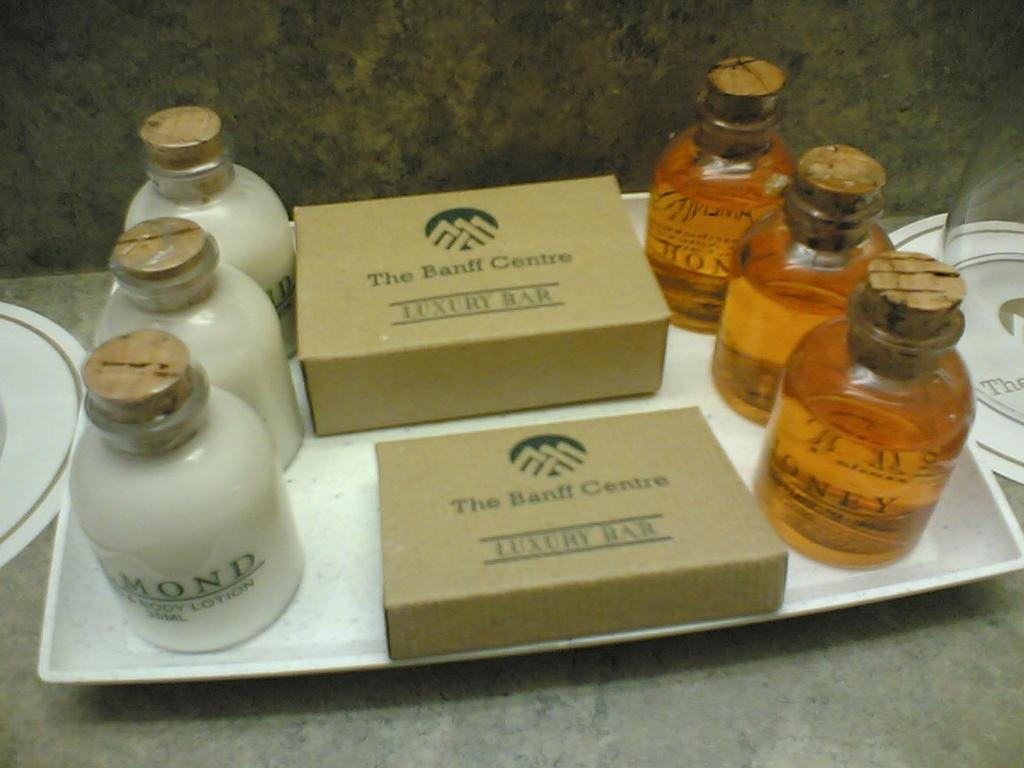<image>
Write a terse but informative summary of the picture. The banf centre hotels provides soaps for their guests 